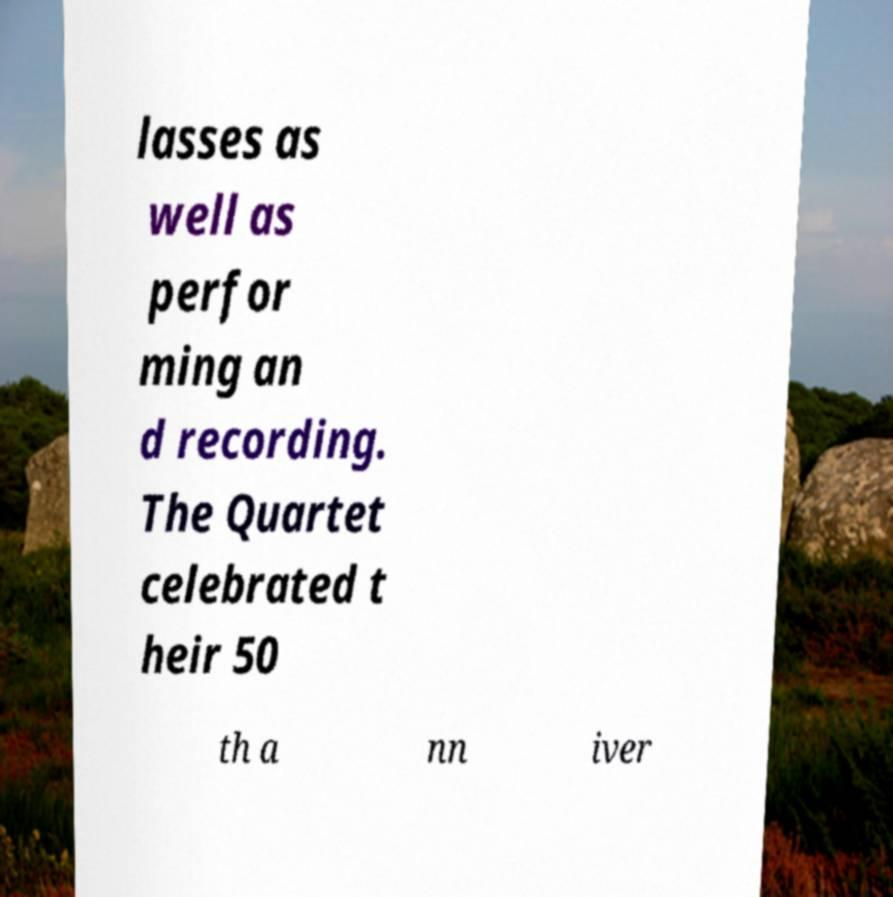Could you extract and type out the text from this image? lasses as well as perfor ming an d recording. The Quartet celebrated t heir 50 th a nn iver 